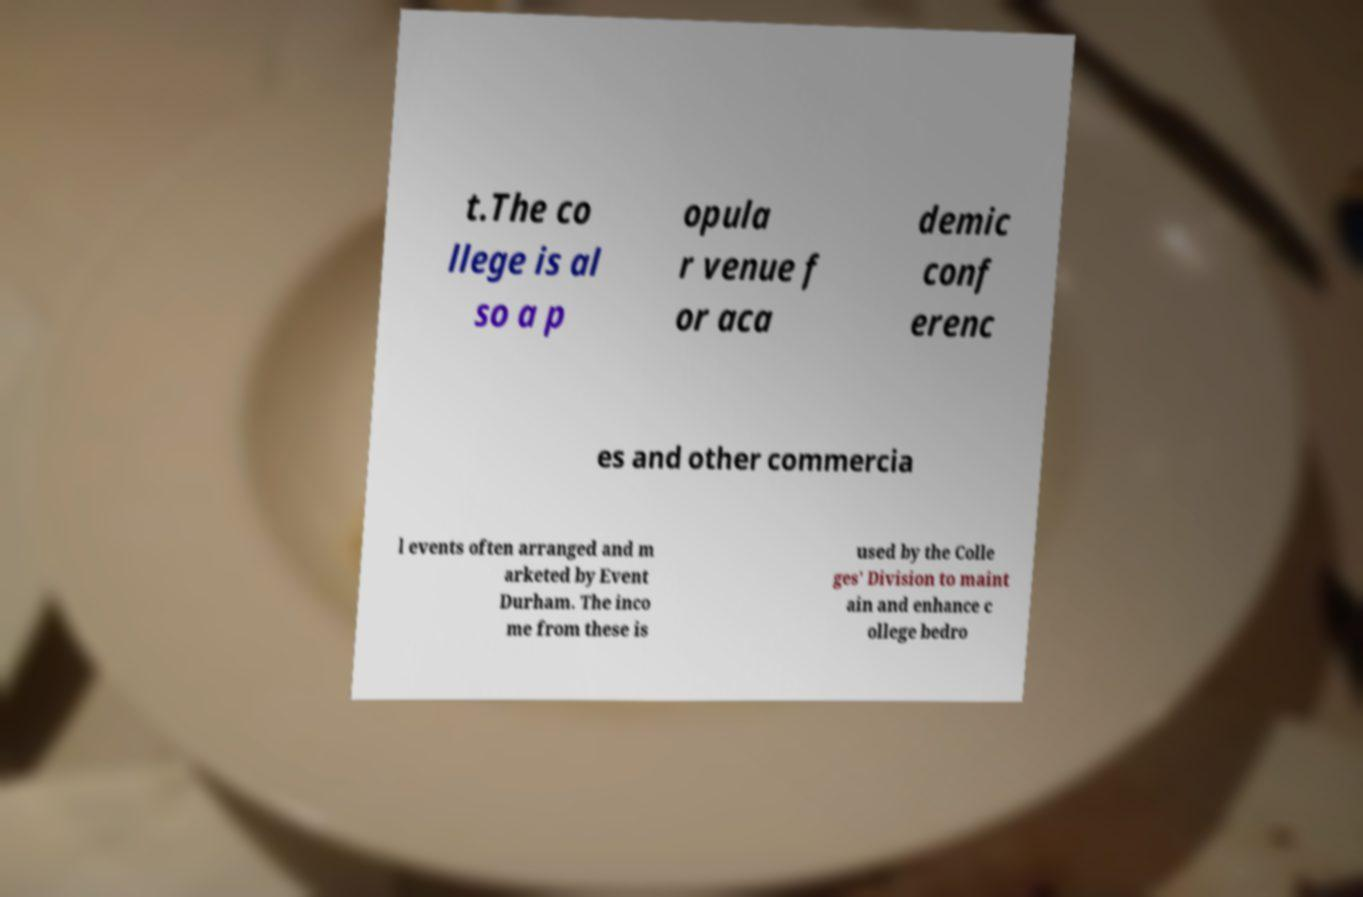Can you accurately transcribe the text from the provided image for me? t.The co llege is al so a p opula r venue f or aca demic conf erenc es and other commercia l events often arranged and m arketed by Event Durham. The inco me from these is used by the Colle ges' Division to maint ain and enhance c ollege bedro 